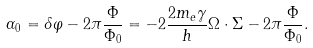<formula> <loc_0><loc_0><loc_500><loc_500>\alpha _ { 0 } = \delta \varphi - 2 \pi \frac { \Phi } { \Phi _ { 0 } } = - 2 \frac { 2 m _ { e } \gamma } { h } { \Omega } \cdot { \Sigma } - 2 \pi \frac { \Phi } { \Phi _ { 0 } } .</formula> 